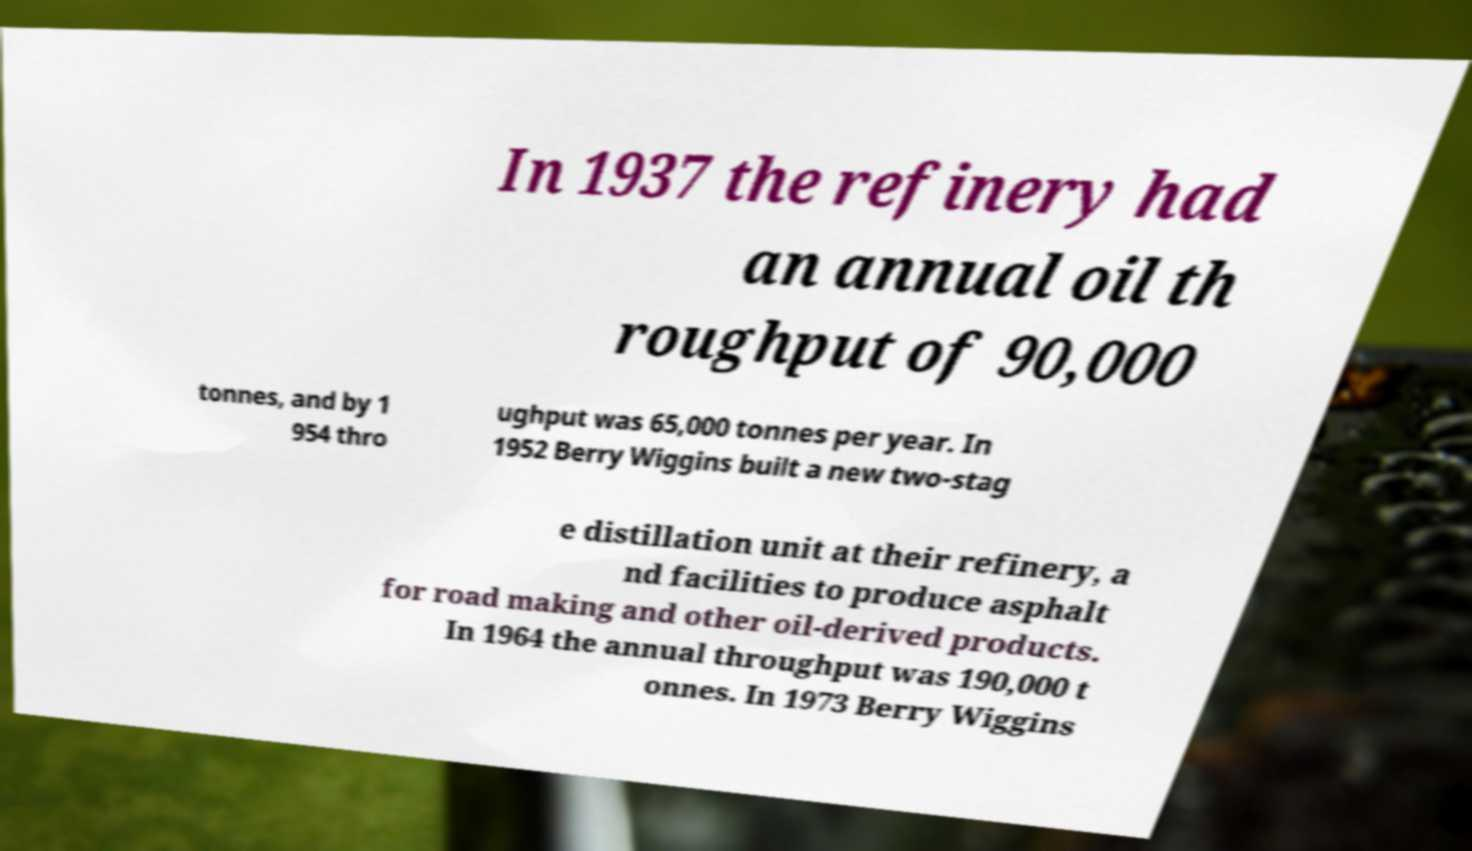Can you read and provide the text displayed in the image?This photo seems to have some interesting text. Can you extract and type it out for me? In 1937 the refinery had an annual oil th roughput of 90,000 tonnes, and by 1 954 thro ughput was 65,000 tonnes per year. In 1952 Berry Wiggins built a new two-stag e distillation unit at their refinery, a nd facilities to produce asphalt for road making and other oil-derived products. In 1964 the annual throughput was 190,000 t onnes. In 1973 Berry Wiggins 